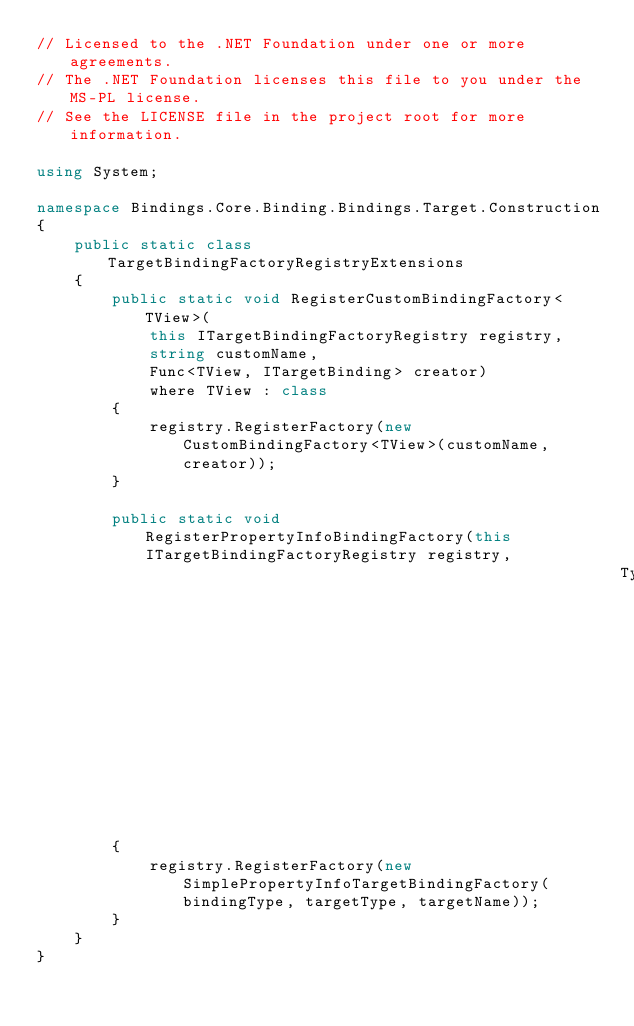<code> <loc_0><loc_0><loc_500><loc_500><_C#_>// Licensed to the .NET Foundation under one or more agreements.
// The .NET Foundation licenses this file to you under the MS-PL license.
// See the LICENSE file in the project root for more information.

using System;

namespace Bindings.Core.Binding.Bindings.Target.Construction
{
    public static class TargetBindingFactoryRegistryExtensions
    {
        public static void RegisterCustomBindingFactory<TView>(
            this ITargetBindingFactoryRegistry registry,
            string customName,
            Func<TView, ITargetBinding> creator)
            where TView : class
        {
            registry.RegisterFactory(new CustomBindingFactory<TView>(customName, creator));
        }

        public static void RegisterPropertyInfoBindingFactory(this ITargetBindingFactoryRegistry registry,
                                                              Type bindingType, Type targetType, string targetName)
        {
            registry.RegisterFactory(new SimplePropertyInfoTargetBindingFactory(bindingType, targetType, targetName));
        }
    }
}</code> 